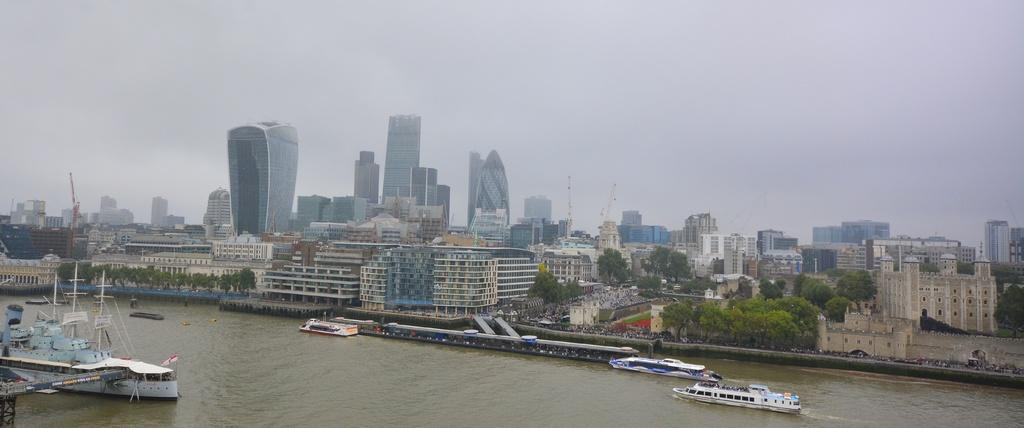What type of vehicles are present in the image? There are boats and a ship in the image. Where are the boats and ship located? They are on the water in the image. What else can be seen in the image besides the boats and ship? There are trees, buildings, and skyscrapers visible in the image. What part of the natural environment is visible in the image? Trees are visible in the image. What is visible in the sky in the image? The sky is visible in the image. What type of shop can be seen in the image? There is no shop present in the image; it features boats, a ship, water, trees, buildings, skyscrapers, and the sky. 